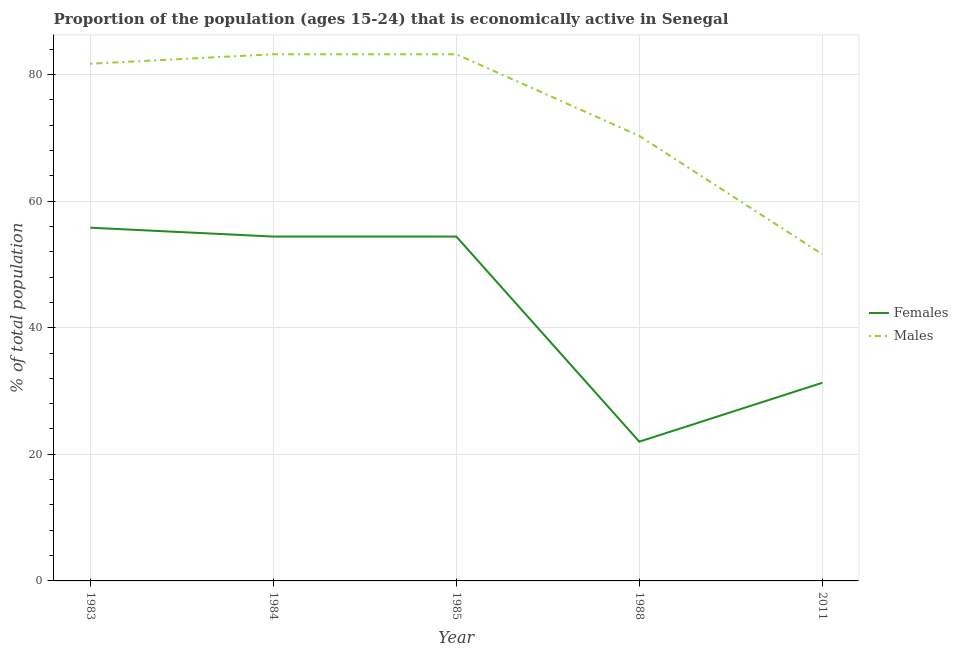How many different coloured lines are there?
Provide a succinct answer. 2. Does the line corresponding to percentage of economically active female population intersect with the line corresponding to percentage of economically active male population?
Your response must be concise. No. What is the percentage of economically active male population in 2011?
Ensure brevity in your answer.  51.6. Across all years, what is the maximum percentage of economically active male population?
Your answer should be compact. 83.2. Across all years, what is the minimum percentage of economically active male population?
Give a very brief answer. 51.6. In which year was the percentage of economically active female population maximum?
Your answer should be very brief. 1983. What is the total percentage of economically active female population in the graph?
Your answer should be very brief. 217.9. What is the difference between the percentage of economically active female population in 1988 and the percentage of economically active male population in 1985?
Provide a short and direct response. -61.2. What is the average percentage of economically active female population per year?
Provide a short and direct response. 43.58. In the year 1985, what is the difference between the percentage of economically active male population and percentage of economically active female population?
Provide a succinct answer. 28.8. In how many years, is the percentage of economically active male population greater than 68 %?
Keep it short and to the point. 4. Is the percentage of economically active female population in 1983 less than that in 1988?
Offer a terse response. No. What is the difference between the highest and the second highest percentage of economically active female population?
Your answer should be very brief. 1.4. What is the difference between the highest and the lowest percentage of economically active female population?
Your response must be concise. 33.8. Is the sum of the percentage of economically active female population in 1984 and 2011 greater than the maximum percentage of economically active male population across all years?
Provide a short and direct response. Yes. Is the percentage of economically active female population strictly greater than the percentage of economically active male population over the years?
Make the answer very short. No. Is the percentage of economically active female population strictly less than the percentage of economically active male population over the years?
Your response must be concise. Yes. How many years are there in the graph?
Make the answer very short. 5. Are the values on the major ticks of Y-axis written in scientific E-notation?
Provide a succinct answer. No. Does the graph contain grids?
Offer a very short reply. Yes. What is the title of the graph?
Ensure brevity in your answer.  Proportion of the population (ages 15-24) that is economically active in Senegal. What is the label or title of the X-axis?
Make the answer very short. Year. What is the label or title of the Y-axis?
Your answer should be compact. % of total population. What is the % of total population of Females in 1983?
Give a very brief answer. 55.8. What is the % of total population of Males in 1983?
Provide a succinct answer. 81.7. What is the % of total population in Females in 1984?
Offer a terse response. 54.4. What is the % of total population in Males in 1984?
Keep it short and to the point. 83.2. What is the % of total population of Females in 1985?
Give a very brief answer. 54.4. What is the % of total population of Males in 1985?
Ensure brevity in your answer.  83.2. What is the % of total population in Males in 1988?
Your answer should be very brief. 70.3. What is the % of total population in Females in 2011?
Make the answer very short. 31.3. What is the % of total population in Males in 2011?
Provide a short and direct response. 51.6. Across all years, what is the maximum % of total population in Females?
Give a very brief answer. 55.8. Across all years, what is the maximum % of total population in Males?
Your answer should be very brief. 83.2. Across all years, what is the minimum % of total population in Females?
Offer a very short reply. 22. Across all years, what is the minimum % of total population of Males?
Give a very brief answer. 51.6. What is the total % of total population of Females in the graph?
Your answer should be very brief. 217.9. What is the total % of total population in Males in the graph?
Ensure brevity in your answer.  370. What is the difference between the % of total population of Females in 1983 and that in 1984?
Offer a very short reply. 1.4. What is the difference between the % of total population in Males in 1983 and that in 1984?
Give a very brief answer. -1.5. What is the difference between the % of total population of Females in 1983 and that in 1985?
Keep it short and to the point. 1.4. What is the difference between the % of total population of Females in 1983 and that in 1988?
Give a very brief answer. 33.8. What is the difference between the % of total population in Males in 1983 and that in 1988?
Offer a very short reply. 11.4. What is the difference between the % of total population of Males in 1983 and that in 2011?
Make the answer very short. 30.1. What is the difference between the % of total population in Females in 1984 and that in 1985?
Your response must be concise. 0. What is the difference between the % of total population in Females in 1984 and that in 1988?
Your answer should be compact. 32.4. What is the difference between the % of total population in Males in 1984 and that in 1988?
Keep it short and to the point. 12.9. What is the difference between the % of total population in Females in 1984 and that in 2011?
Ensure brevity in your answer.  23.1. What is the difference between the % of total population in Males in 1984 and that in 2011?
Keep it short and to the point. 31.6. What is the difference between the % of total population in Females in 1985 and that in 1988?
Offer a very short reply. 32.4. What is the difference between the % of total population in Females in 1985 and that in 2011?
Offer a terse response. 23.1. What is the difference between the % of total population of Males in 1985 and that in 2011?
Your response must be concise. 31.6. What is the difference between the % of total population in Females in 1988 and that in 2011?
Your answer should be very brief. -9.3. What is the difference between the % of total population of Females in 1983 and the % of total population of Males in 1984?
Keep it short and to the point. -27.4. What is the difference between the % of total population of Females in 1983 and the % of total population of Males in 1985?
Provide a succinct answer. -27.4. What is the difference between the % of total population in Females in 1983 and the % of total population in Males in 2011?
Give a very brief answer. 4.2. What is the difference between the % of total population in Females in 1984 and the % of total population in Males in 1985?
Your answer should be very brief. -28.8. What is the difference between the % of total population of Females in 1984 and the % of total population of Males in 1988?
Keep it short and to the point. -15.9. What is the difference between the % of total population of Females in 1984 and the % of total population of Males in 2011?
Offer a terse response. 2.8. What is the difference between the % of total population in Females in 1985 and the % of total population in Males in 1988?
Your answer should be compact. -15.9. What is the difference between the % of total population in Females in 1985 and the % of total population in Males in 2011?
Provide a succinct answer. 2.8. What is the difference between the % of total population of Females in 1988 and the % of total population of Males in 2011?
Make the answer very short. -29.6. What is the average % of total population in Females per year?
Provide a short and direct response. 43.58. In the year 1983, what is the difference between the % of total population of Females and % of total population of Males?
Your answer should be compact. -25.9. In the year 1984, what is the difference between the % of total population in Females and % of total population in Males?
Your response must be concise. -28.8. In the year 1985, what is the difference between the % of total population in Females and % of total population in Males?
Your answer should be compact. -28.8. In the year 1988, what is the difference between the % of total population in Females and % of total population in Males?
Keep it short and to the point. -48.3. In the year 2011, what is the difference between the % of total population of Females and % of total population of Males?
Offer a terse response. -20.3. What is the ratio of the % of total population in Females in 1983 to that in 1984?
Your answer should be compact. 1.03. What is the ratio of the % of total population of Females in 1983 to that in 1985?
Your answer should be very brief. 1.03. What is the ratio of the % of total population of Males in 1983 to that in 1985?
Provide a succinct answer. 0.98. What is the ratio of the % of total population in Females in 1983 to that in 1988?
Offer a terse response. 2.54. What is the ratio of the % of total population of Males in 1983 to that in 1988?
Give a very brief answer. 1.16. What is the ratio of the % of total population in Females in 1983 to that in 2011?
Ensure brevity in your answer.  1.78. What is the ratio of the % of total population of Males in 1983 to that in 2011?
Give a very brief answer. 1.58. What is the ratio of the % of total population in Females in 1984 to that in 1985?
Your answer should be compact. 1. What is the ratio of the % of total population in Females in 1984 to that in 1988?
Give a very brief answer. 2.47. What is the ratio of the % of total population of Males in 1984 to that in 1988?
Your answer should be very brief. 1.18. What is the ratio of the % of total population in Females in 1984 to that in 2011?
Make the answer very short. 1.74. What is the ratio of the % of total population in Males in 1984 to that in 2011?
Offer a very short reply. 1.61. What is the ratio of the % of total population of Females in 1985 to that in 1988?
Ensure brevity in your answer.  2.47. What is the ratio of the % of total population in Males in 1985 to that in 1988?
Keep it short and to the point. 1.18. What is the ratio of the % of total population in Females in 1985 to that in 2011?
Give a very brief answer. 1.74. What is the ratio of the % of total population in Males in 1985 to that in 2011?
Offer a very short reply. 1.61. What is the ratio of the % of total population of Females in 1988 to that in 2011?
Ensure brevity in your answer.  0.7. What is the ratio of the % of total population in Males in 1988 to that in 2011?
Your answer should be compact. 1.36. What is the difference between the highest and the second highest % of total population of Females?
Offer a terse response. 1.4. What is the difference between the highest and the lowest % of total population in Females?
Offer a very short reply. 33.8. What is the difference between the highest and the lowest % of total population in Males?
Provide a short and direct response. 31.6. 